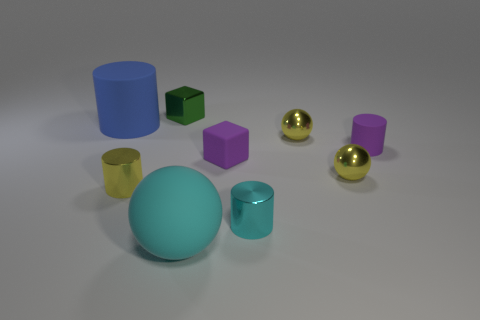Subtract 1 cylinders. How many cylinders are left? 3 Subtract all gray cylinders. Subtract all green blocks. How many cylinders are left? 4 Add 1 yellow metallic spheres. How many objects exist? 10 Subtract all spheres. How many objects are left? 6 Add 6 small matte things. How many small matte things exist? 8 Subtract 1 blue cylinders. How many objects are left? 8 Subtract all metallic things. Subtract all small shiny cubes. How many objects are left? 3 Add 1 small things. How many small things are left? 8 